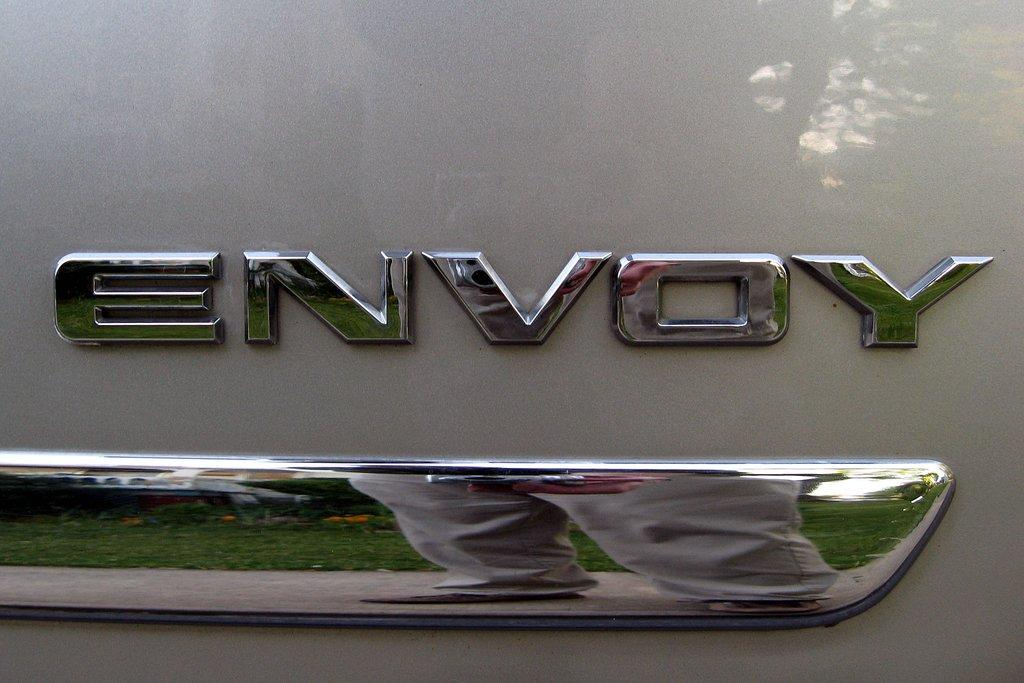What part of a vehicle can be seen in the image? There is a part of a vehicle with a name in the image. What other object is present in the image? There is a steel bar in the image. Who or what is on the steel bar? Legs of a person are visible on the steel bar. What type of natural environment is visible in the image? Grass is present in the image. Can you tell me how many jokes are being told in the image? There is no indication of any jokes being told in the image. Is there an ocean visible in the image? No, there is no ocean present in the image; only grass is visible. 